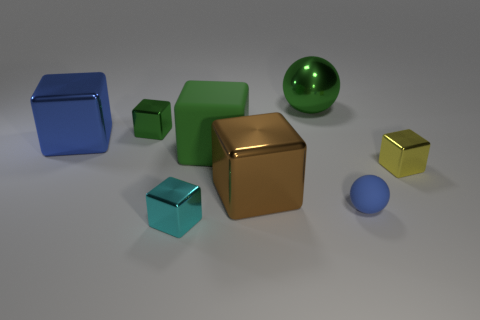Subtract all large brown metal blocks. How many blocks are left? 5 Subtract all cyan spheres. How many green cubes are left? 2 Subtract all yellow blocks. How many blocks are left? 5 Subtract 4 blocks. How many blocks are left? 2 Subtract all cyan blocks. Subtract all purple spheres. How many blocks are left? 5 Add 1 yellow blocks. How many objects exist? 9 Subtract all balls. How many objects are left? 6 Subtract all green cubes. Subtract all rubber cubes. How many objects are left? 5 Add 3 metallic balls. How many metallic balls are left? 4 Add 1 blue balls. How many blue balls exist? 2 